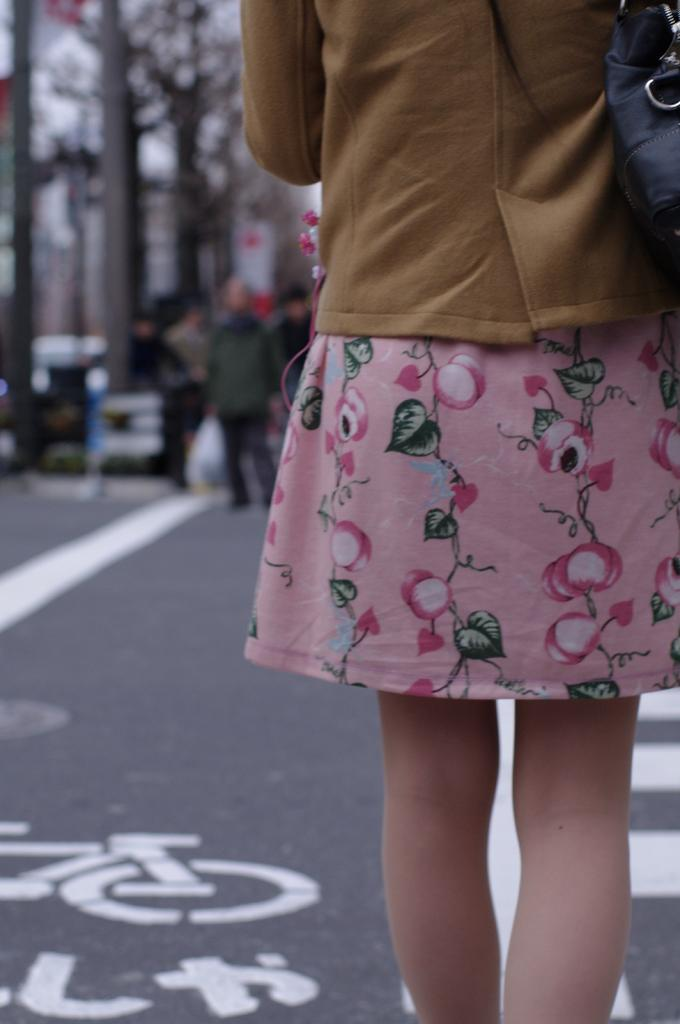Who is the main subject in the foreground of the image? There is a girl in the foreground of the image. What is located at the bottom of the image? There is a road at the bottom of the image. What can be seen in the background of the image? There are people and trees in the background of the image. What type of drug is being sold in the hall in the image? There is no hall or drug present in the image. 